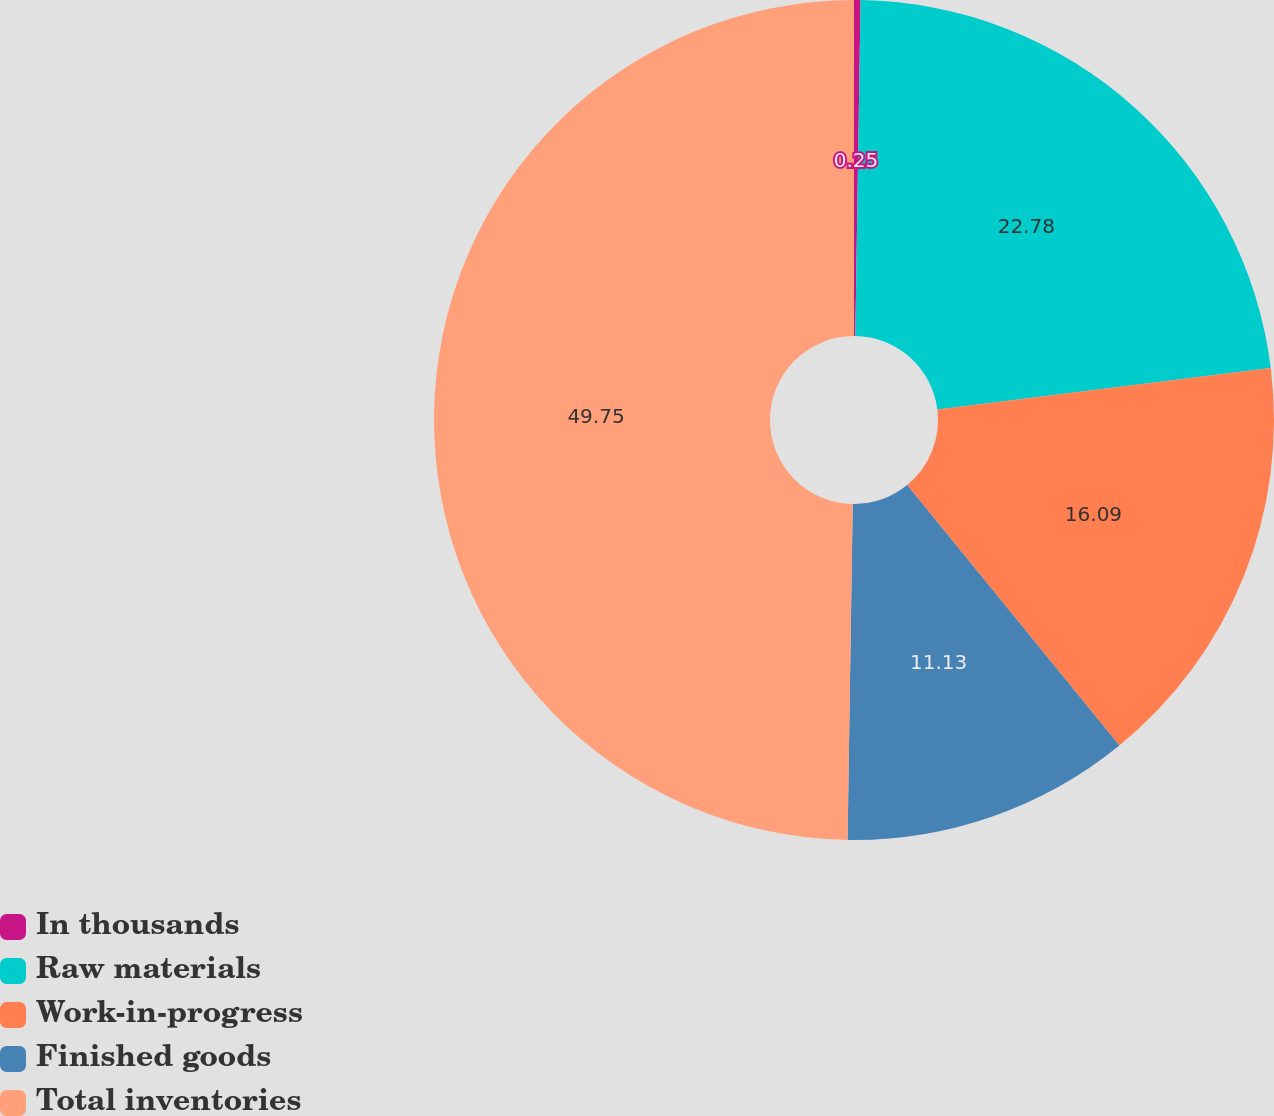<chart> <loc_0><loc_0><loc_500><loc_500><pie_chart><fcel>In thousands<fcel>Raw materials<fcel>Work-in-progress<fcel>Finished goods<fcel>Total inventories<nl><fcel>0.25%<fcel>22.78%<fcel>16.09%<fcel>11.13%<fcel>49.76%<nl></chart> 